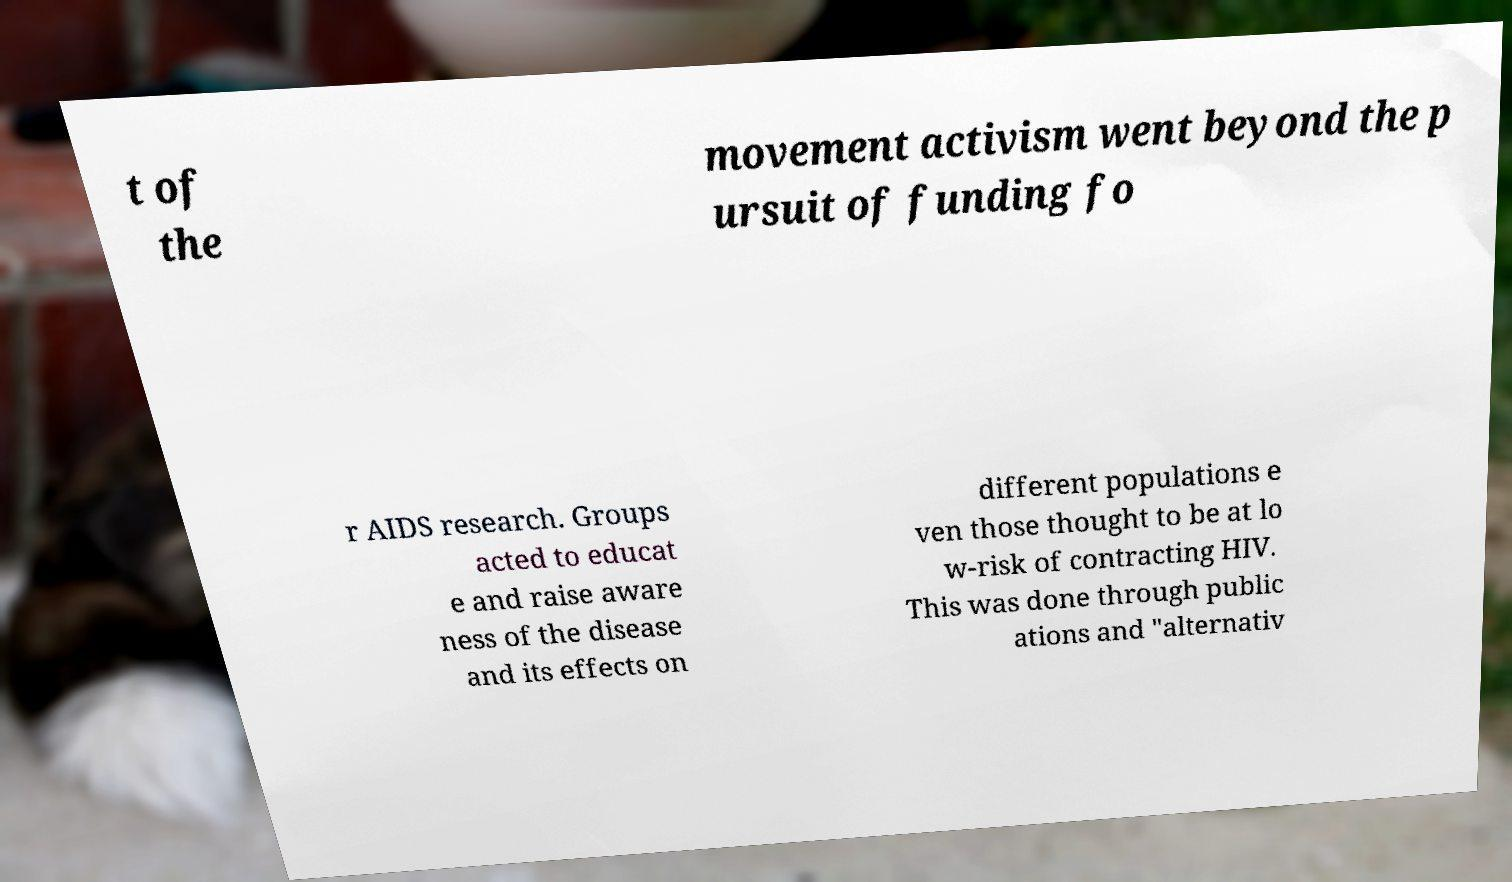Could you assist in decoding the text presented in this image and type it out clearly? t of the movement activism went beyond the p ursuit of funding fo r AIDS research. Groups acted to educat e and raise aware ness of the disease and its effects on different populations e ven those thought to be at lo w-risk of contracting HIV. This was done through public ations and "alternativ 